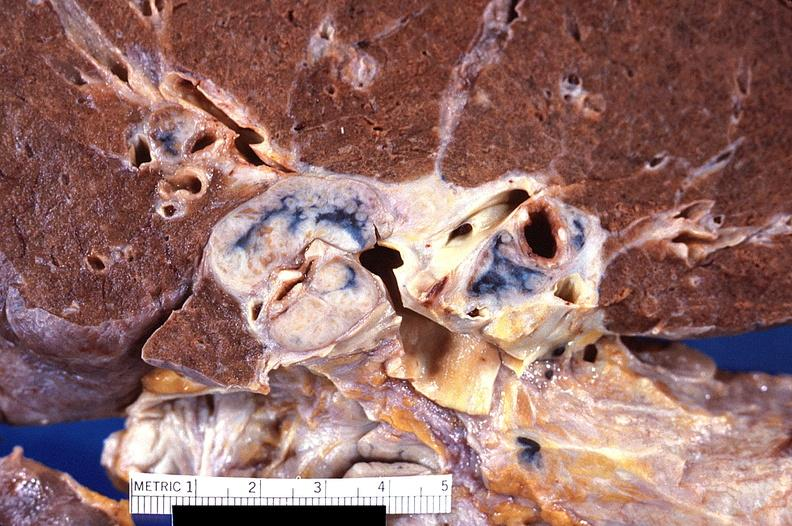does this image show hilar lymph nodes, nodular sclerosing hodgkins disease?
Answer the question using a single word or phrase. Yes 